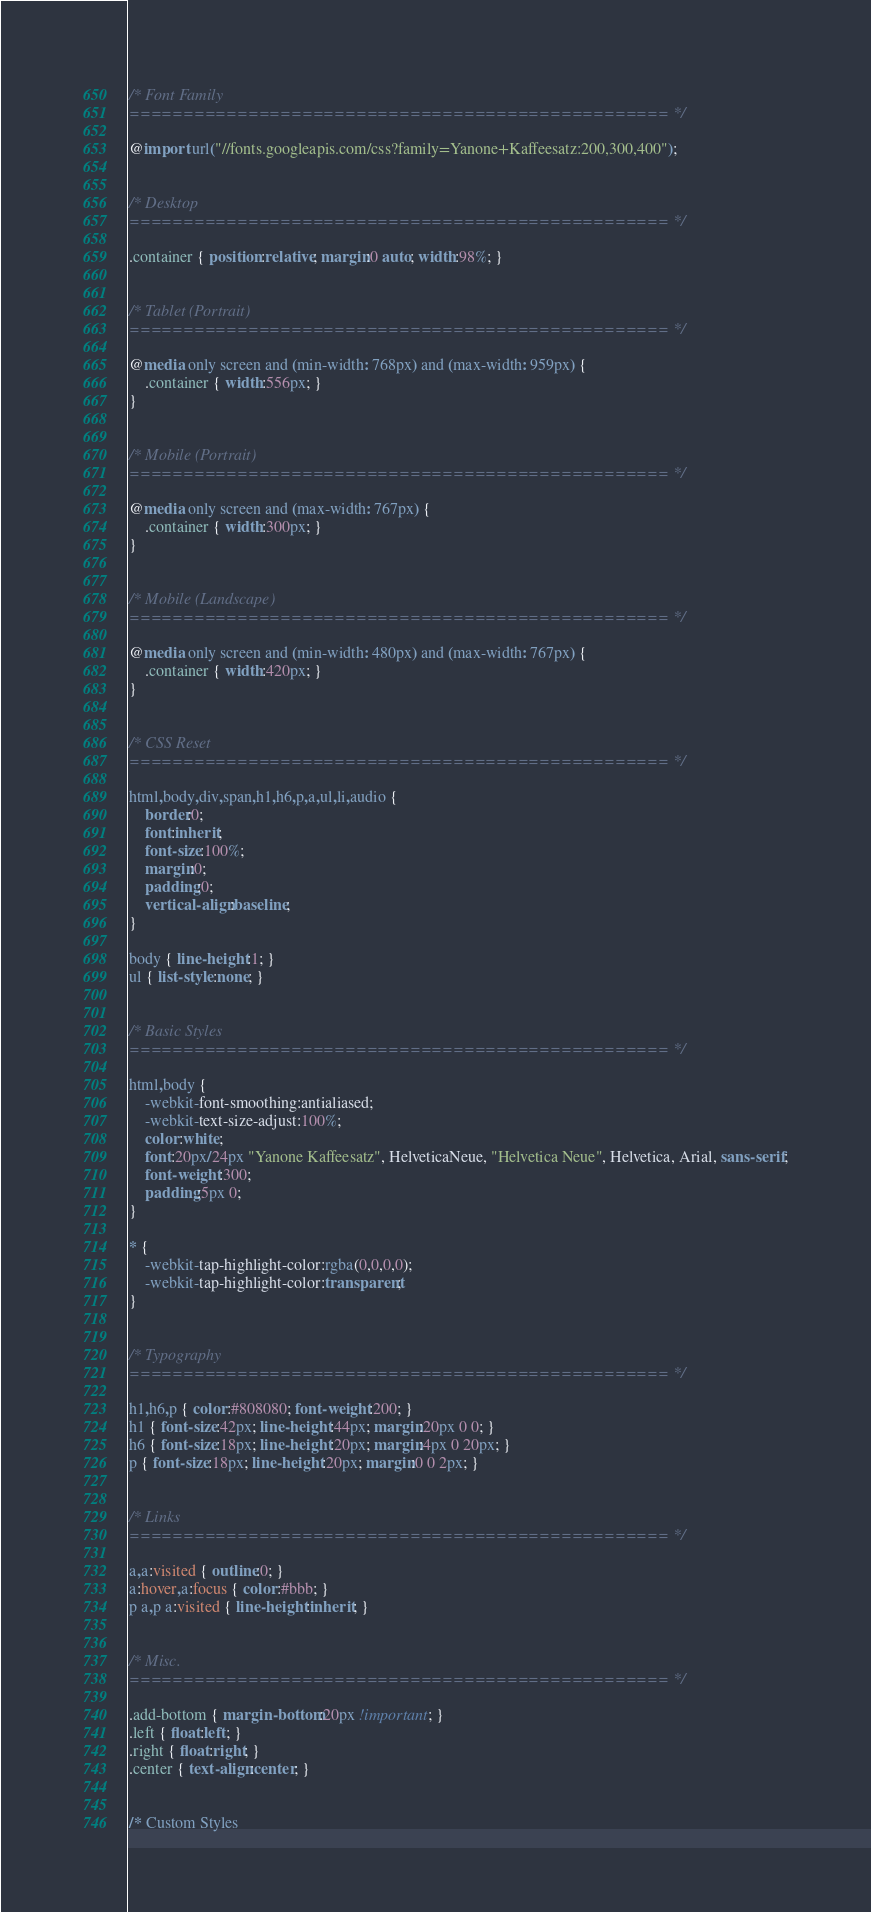Convert code to text. <code><loc_0><loc_0><loc_500><loc_500><_CSS_>
/* Font Family
================================================== */

@import url("//fonts.googleapis.com/css?family=Yanone+Kaffeesatz:200,300,400");


/* Desktop
================================================== */

.container { position:relative; margin:0 auto; width:98%; }


/* Tablet (Portrait)
================================================== */

@media only screen and (min-width: 768px) and (max-width: 959px) {
    .container { width:556px; }
}


/* Mobile (Portrait)
================================================== */

@media only screen and (max-width: 767px) {
    .container { width:300px; }
}


/* Mobile (Landscape)
================================================== */

@media only screen and (min-width: 480px) and (max-width: 767px) {
    .container { width:420px; }
}


/* CSS Reset
================================================== */

html,body,div,span,h1,h6,p,a,ul,li,audio {
    border:0;
    font:inherit;
    font-size:100%;
    margin:0;
    padding:0;
    vertical-align:baseline;
}

body { line-height:1; }
ul { list-style:none; }


/* Basic Styles
================================================== */

html,body {
    -webkit-font-smoothing:antialiased;
    -webkit-text-size-adjust:100%;
    color:white;
    font:20px/24px "Yanone Kaffeesatz", HelveticaNeue, "Helvetica Neue", Helvetica, Arial, sans-serif;
    font-weight:300;
    padding:5px 0;
}

* {
    -webkit-tap-highlight-color:rgba(0,0,0,0);
    -webkit-tap-highlight-color:transparent;
}


/* Typography
================================================== */

h1,h6,p { color:#808080; font-weight:200; }
h1 { font-size:42px; line-height:44px; margin:20px 0 0; }
h6 { font-size:18px; line-height:20px; margin:4px 0 20px; }
p { font-size:18px; line-height:20px; margin:0 0 2px; }


/* Links
================================================== */

a,a:visited { outline:0; }
a:hover,a:focus { color:#bbb; }
p a,p a:visited { line-height:inherit; }


/* Misc.
================================================== */

.add-bottom { margin-bottom:20px !important; }
.left { float:left; }
.right { float:right; }
.center { text-align:center; }


/* Custom Styles</code> 